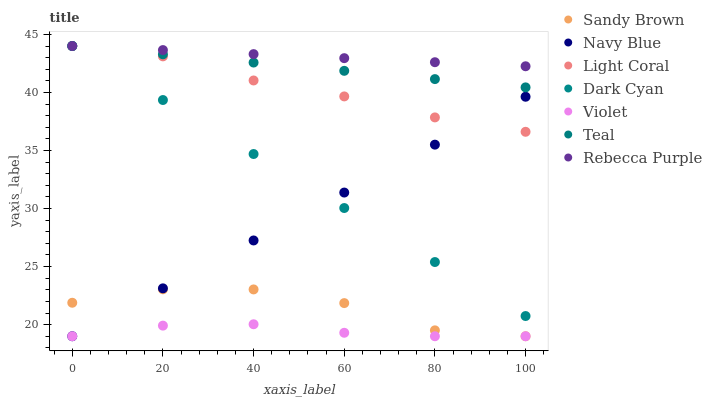Does Violet have the minimum area under the curve?
Answer yes or no. Yes. Does Rebecca Purple have the maximum area under the curve?
Answer yes or no. Yes. Does Light Coral have the minimum area under the curve?
Answer yes or no. No. Does Light Coral have the maximum area under the curve?
Answer yes or no. No. Is Navy Blue the smoothest?
Answer yes or no. Yes. Is Sandy Brown the roughest?
Answer yes or no. Yes. Is Light Coral the smoothest?
Answer yes or no. No. Is Light Coral the roughest?
Answer yes or no. No. Does Navy Blue have the lowest value?
Answer yes or no. Yes. Does Light Coral have the lowest value?
Answer yes or no. No. Does Dark Cyan have the highest value?
Answer yes or no. Yes. Does Violet have the highest value?
Answer yes or no. No. Is Sandy Brown less than Teal?
Answer yes or no. Yes. Is Dark Cyan greater than Violet?
Answer yes or no. Yes. Does Light Coral intersect Dark Cyan?
Answer yes or no. Yes. Is Light Coral less than Dark Cyan?
Answer yes or no. No. Is Light Coral greater than Dark Cyan?
Answer yes or no. No. Does Sandy Brown intersect Teal?
Answer yes or no. No. 